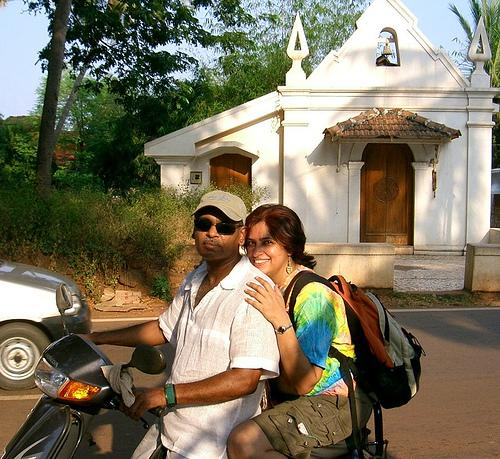What season is most likely? summer 